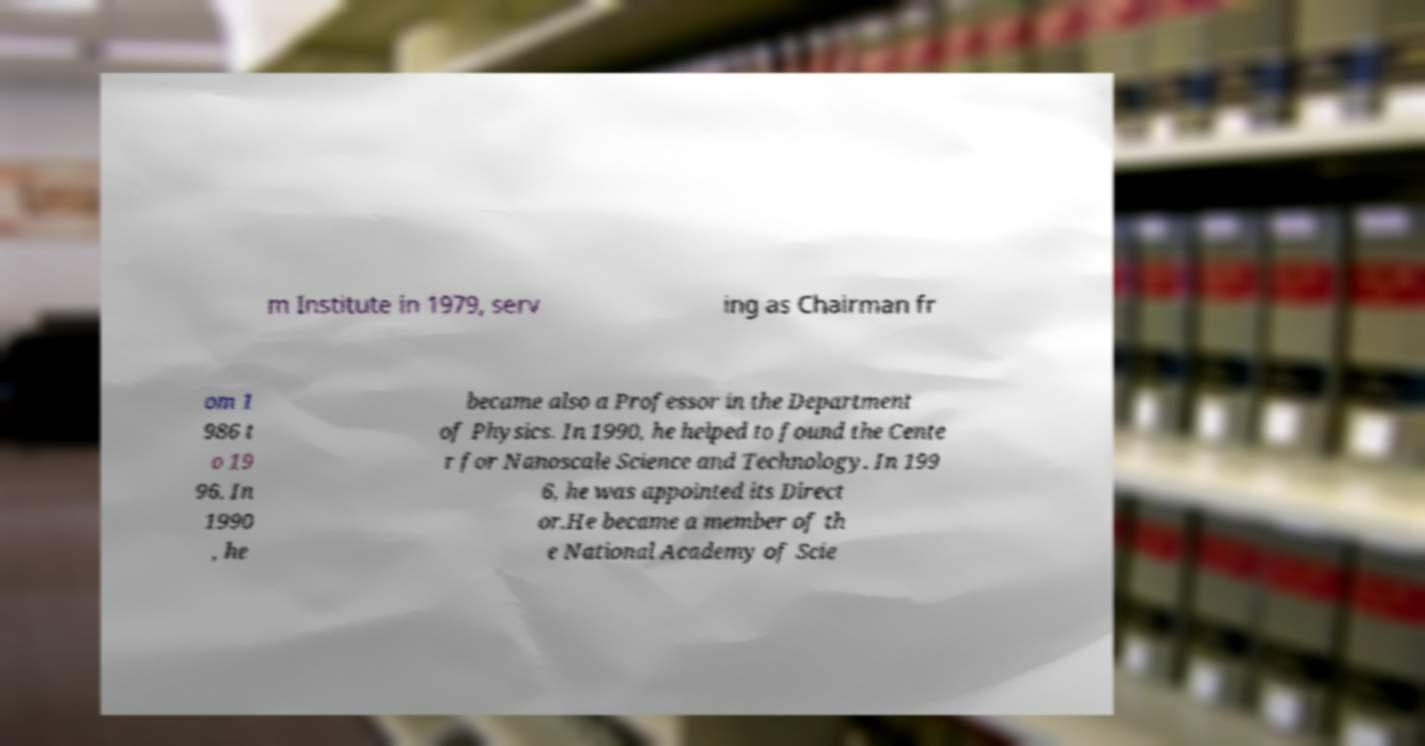For documentation purposes, I need the text within this image transcribed. Could you provide that? m Institute in 1979, serv ing as Chairman fr om 1 986 t o 19 96. In 1990 , he became also a Professor in the Department of Physics. In 1990, he helped to found the Cente r for Nanoscale Science and Technology. In 199 6, he was appointed its Direct or.He became a member of th e National Academy of Scie 